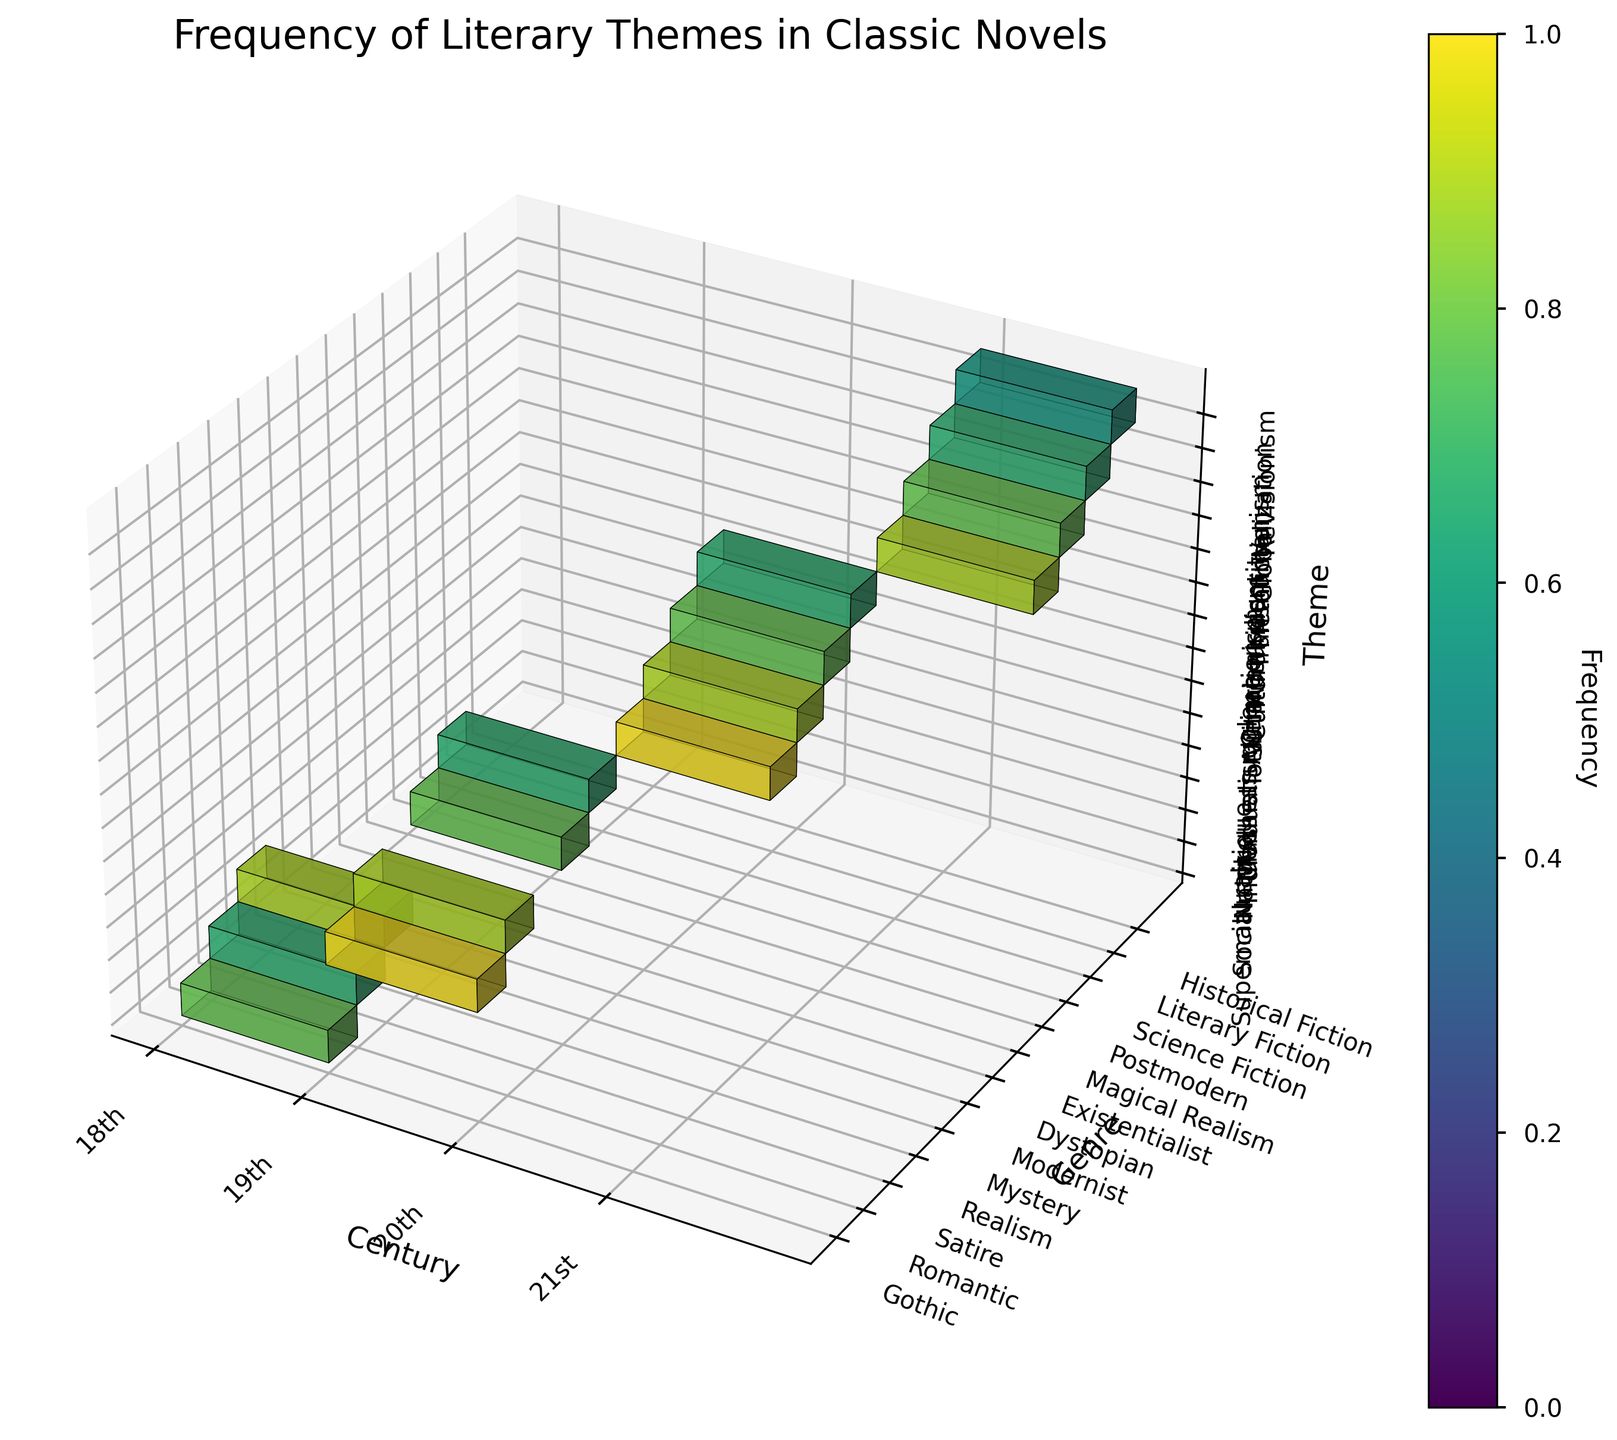What is the title of the plot? The title is usually displayed at the top of the plot. In this case, the title is "Frequency of Literary Themes in Classic Novels."
Answer: Frequency of Literary Themes in Classic Novels Which genre has the highest frequency of themes in the 19th century? To find the genre with the highest frequency in the 19th century, look at the 19th century along the x-axis and then find the genre along the y-axis with the highest voxel height (or intensity). Gothic with Madness has the highest voxel.
Answer: Gothic What is the theme with the lowest frequency in the 21st century? Look along the x-axis for the 21st century, then find the smallest voxel height or intensity among all themes along the z-axis. The lowest is for Revisionism in Historical Fiction.
Answer: Revisionism What are the different genres represented in the 18th century? To find the different genres for the 18th century, look along the x-axis for the 18th century and identify the genres represented on the y-axis. The genres are Gothic, Romantic, and Satire.
Answer: Gothic, Romantic, Satire Which century has the theme of Individualism in Romantic genre and what is its frequency? Locate Individualism on the z-axis and Romantic on the y-axis, then trace it back to the x-axis to find the corresponding century and the height of the voxel for its frequency. Individualism in the Romantic genre appears in the 19th century with a frequency of 8.
Answer: 19th century, 8 How does the frequency of Social critique in Satire genre in the 18th century compare to Transhumanism in Science Fiction in the 21st century? Identify the two voxels: Social critique in Satire (18th century) and Transhumanism in Science Fiction (21st century). Compare their heights or color intensities. Social critique has a frequency of 8, and Transhumanism has a frequency of 7.
Answer: Social critique is higher than Transhumanism What is the most frequent theme in the 20th century, and in which genre does it appear? Look at the 20th century on the x-axis and find the tallest voxel (most frequent theme), then identify its respective genre on the y-axis. Alienation in Modernist is the most frequent theme.
Answer: Alienation in Modernist Which genre has the largest number of different themes in the entire dataset? Examine each genre along the y-axis and count the number of different themes represented along the z-axis voxels. Multiple genres have only one voxel, indicating an equal number of themes.
Answer: Multiple genres have equal numbers 